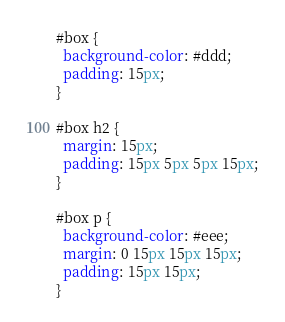<code> <loc_0><loc_0><loc_500><loc_500><_CSS_>#box {
  background-color: #ddd;
  padding: 15px;
}

#box h2 {
  margin: 15px;
  padding: 15px 5px 5px 15px;
}

#box p {
  background-color: #eee;
  margin: 0 15px 15px 15px;
  padding: 15px 15px;
}
</code> 